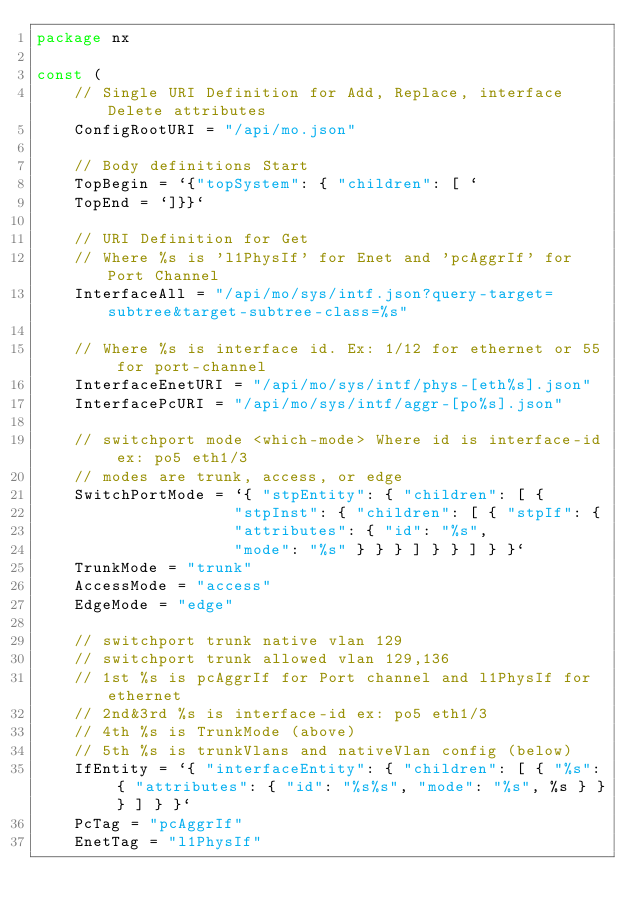<code> <loc_0><loc_0><loc_500><loc_500><_Go_>package nx

const (
    // Single URI Definition for Add, Replace, interface Delete attributes
    ConfigRootURI = "/api/mo.json"

    // Body definitions Start
    TopBegin = `{"topSystem": { "children": [ `
    TopEnd = `]}}`

    // URI Definition for Get
    // Where %s is 'l1PhysIf' for Enet and 'pcAggrIf' for Port Channel
    InterfaceAll = "/api/mo/sys/intf.json?query-target=subtree&target-subtree-class=%s"

    // Where %s is interface id. Ex: 1/12 for ethernet or 55 for port-channel
    InterfaceEnetURI = "/api/mo/sys/intf/phys-[eth%s].json"
    InterfacePcURI = "/api/mo/sys/intf/aggr-[po%s].json"

    // switchport mode <which-mode> Where id is interface-id ex: po5 eth1/3
    // modes are trunk, access, or edge
    SwitchPortMode = `{ "stpEntity": { "children": [ {
                     "stpInst": { "children": [ { "stpIf": {
                     "attributes": { "id": "%s",
                     "mode": "%s" } } } ] } } ] } }`
    TrunkMode = "trunk"
    AccessMode = "access"
    EdgeMode = "edge"

    // switchport trunk native vlan 129
    // switchport trunk allowed vlan 129,136
    // 1st %s is pcAggrIf for Port channel and l1PhysIf for ethernet
    // 2nd&3rd %s is interface-id ex: po5 eth1/3
    // 4th %s is TrunkMode (above)
    // 5th %s is trunkVlans and nativeVlan config (below)
    IfEntity = `{ "interfaceEntity": { "children": [ { "%s": { "attributes": { "id": "%s%s", "mode": "%s", %s } } } ] } }`
    PcTag = "pcAggrIf"
    EnetTag = "l1PhysIf"</code> 